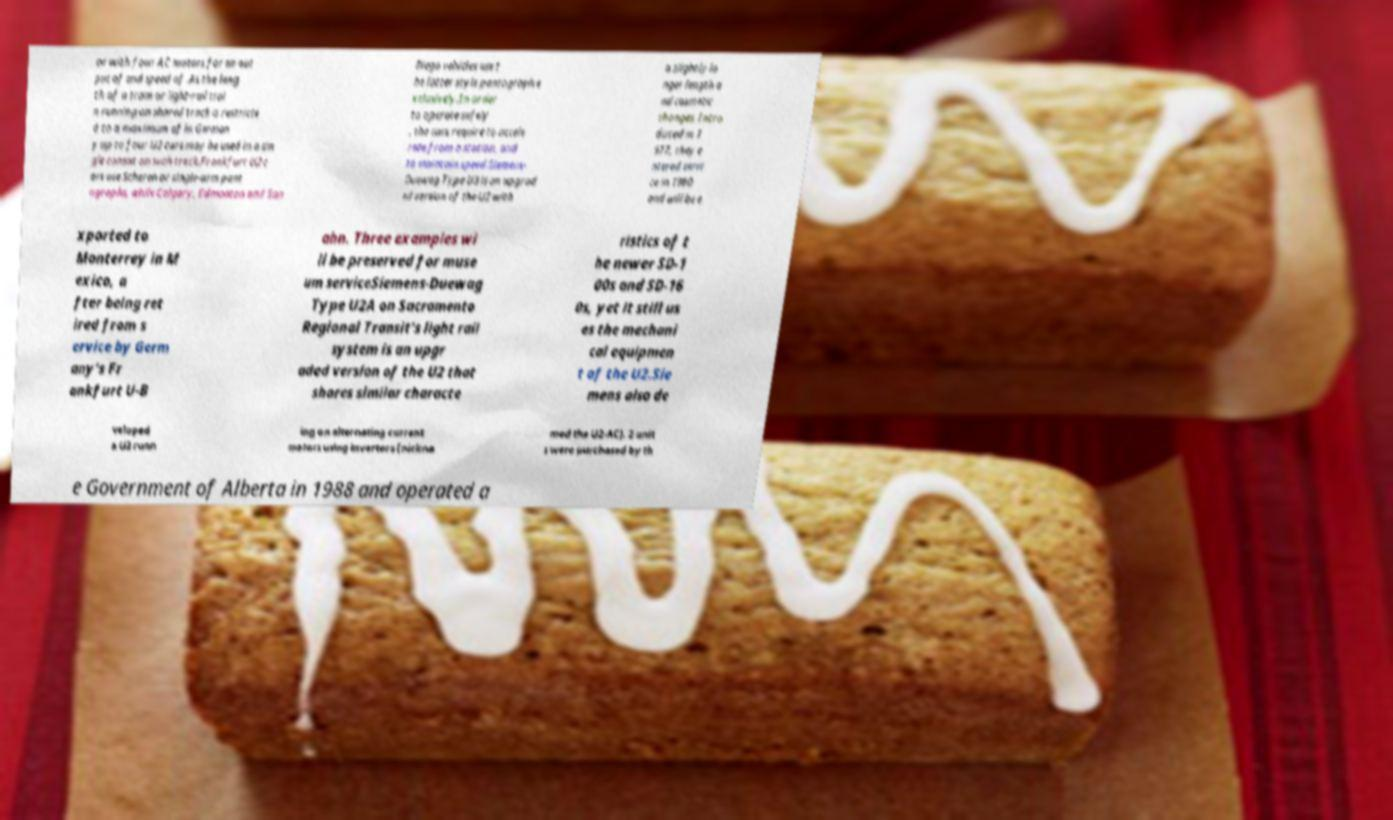For documentation purposes, I need the text within this image transcribed. Could you provide that? or with four AC motors for an out put of and speed of .As the leng th of a tram or light-rail trai n running on shared track is restricte d to a maximum of in German y up to four U2 cars may be used in a sin gle consist on such track.Frankfurt U2 c ars use Scheren or single-arm pant ographs, while Calgary, Edmonton and San Diego vehicles use t he latter style pantograph e xclusively.In order to operate safely , the cars require to accele rate from a station, and to maintain speed.Siemens- Duewag Type U3 is an upgrad ed version of the U2 with a slightly lo nger length a nd cosmetic changes. Intro duced in 1 977, they e ntered servi ce in 1980 and will be e xported to Monterrey in M exico, a fter being ret ired from s ervice by Germ any's Fr ankfurt U-B ahn. Three examples wi ll be preserved for muse um serviceSiemens-Duewag Type U2A on Sacramento Regional Transit's light rail system is an upgr aded version of the U2 that shares similar characte ristics of t he newer SD-1 00s and SD-16 0s, yet it still us es the mechani cal equipmen t of the U2.Sie mens also de veloped a U2 runn ing on alternating current motors using inverters (nickna med the U2-AC). 2 unit s were purchased by th e Government of Alberta in 1988 and operated a 